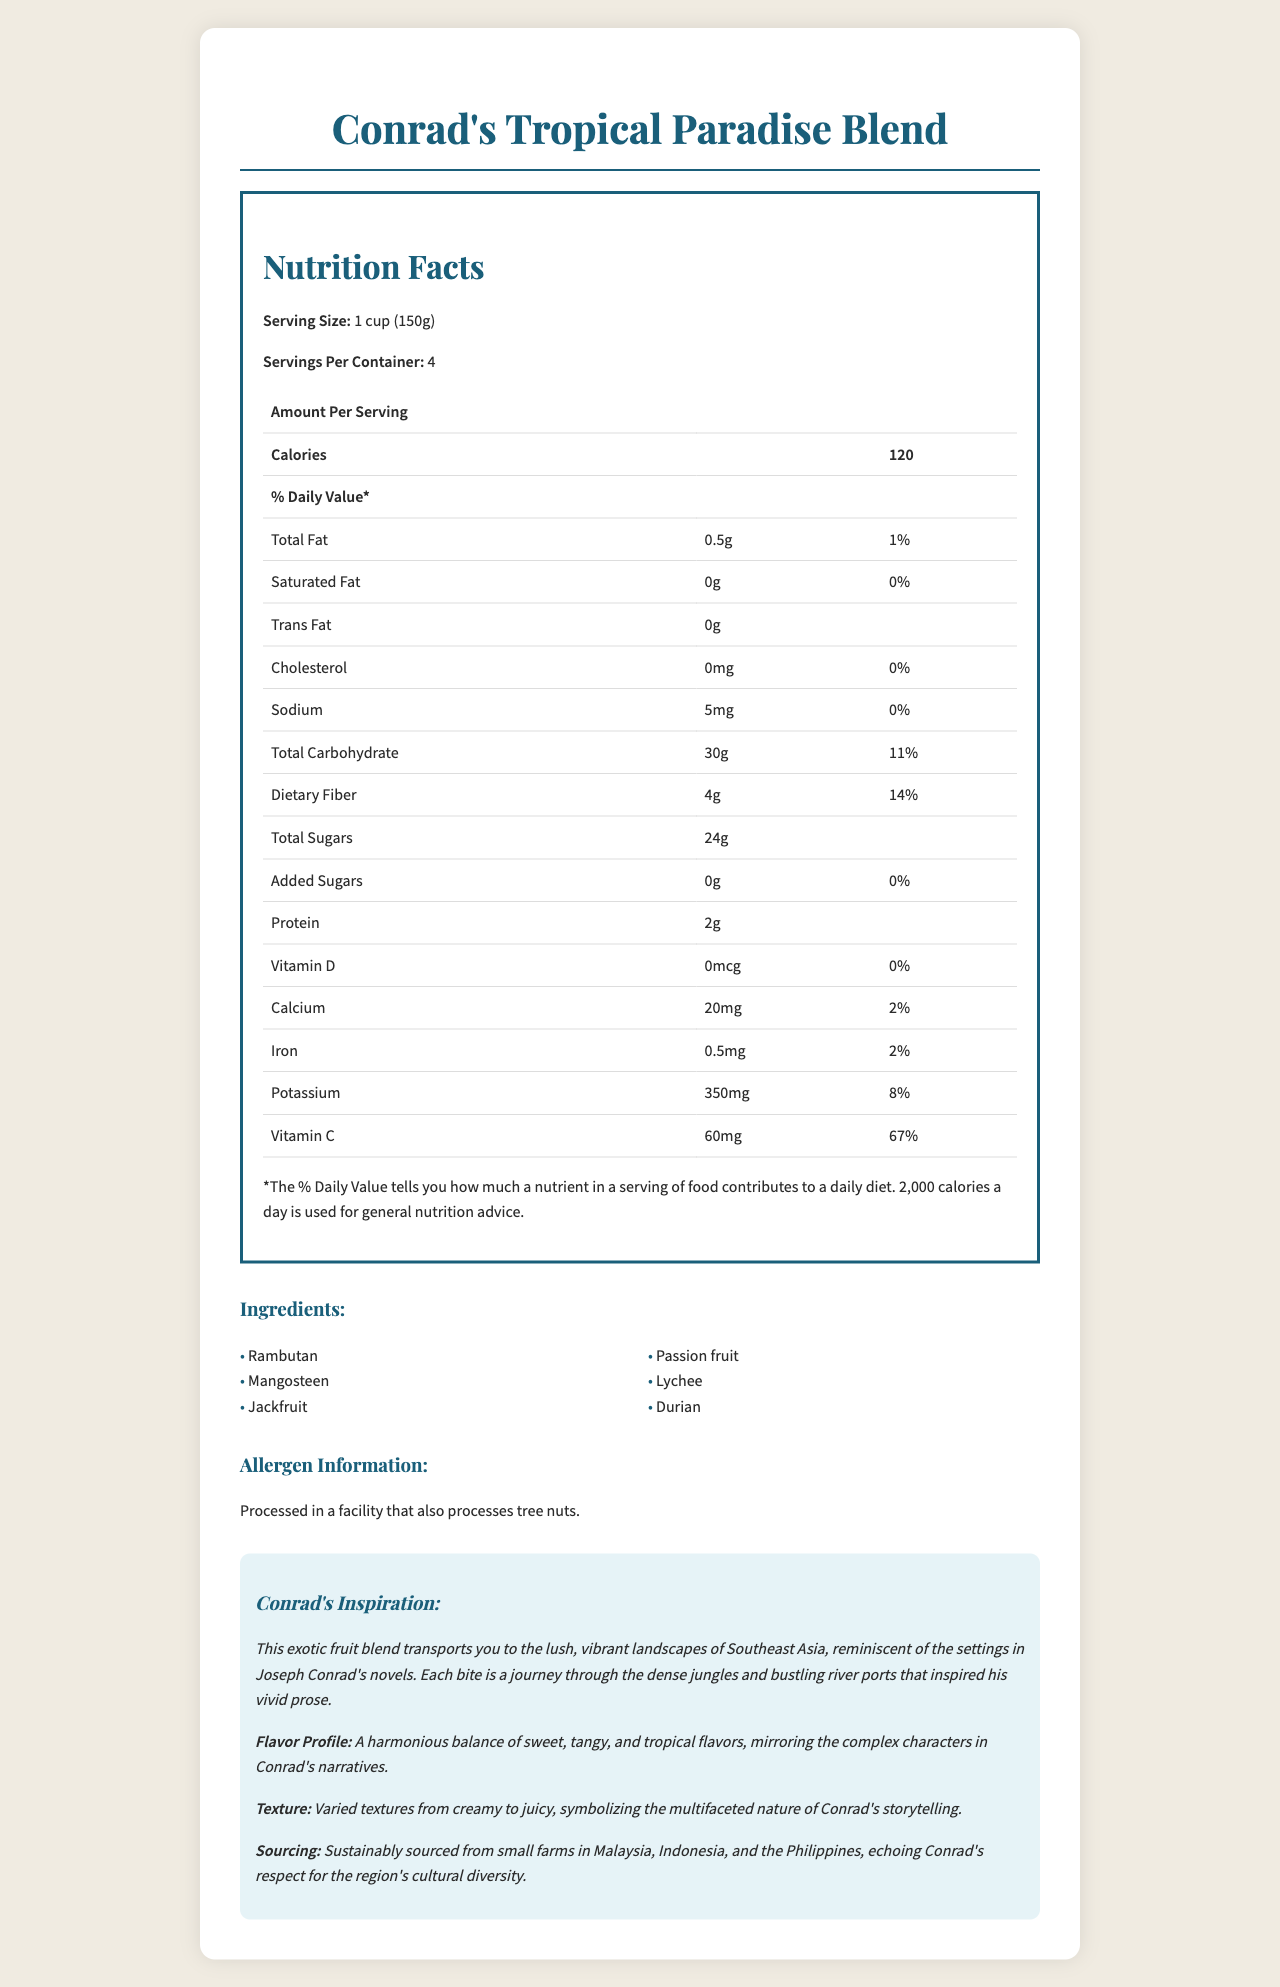what is the serving size of Conrad's Tropical Paradise Blend? The serving size is explicitly stated as "1 cup (150g)" in the nutrition facts section.
Answer: 1 cup (150g) how many calories are in one serving? The calories per serving are listed as 120 in the nutrition facts section.
Answer: 120 what is the total fat content per serving? The total fat content per serving is 0.5g, mentioned under the Total Fat entry.
Answer: 0.5g how many grams of dietary fiber does one serving contain? The dietary fiber per serving is detailed as 4g in the nutrition facts table.
Answer: 4g What fruits are included in the ingredients list? The ingredients listed are Rambutan, Mangosteen, Jackfruit, Passion fruit, Lychee, and Durian.
Answer: Rambutan, Mangosteen, Jackfruit, Passion fruit, Lychee, Durian how much sodium does one serving contain? The sodium content per serving is listed as 5mg in the nutrition facts table.
Answer: 5mg Are there any added sugars in this product? Yes/No The entry for added sugars explicitly states "0g", meaning there are no added sugars.
Answer: No Which nutrient has the highest % Daily Value? A. Vitamin D B. Vitamin C C. Calcium D. Iron Vitamin C has the highest daily value at 67%, as listed in the nutrition facts table.
Answer: B. Vitamin C What is the % Daily Value of calcium? A. 2% B. 8% C. 67% D. 14% The calcium % Daily Value is listed as 2% in the nutrition facts section.
Answer: A. 2% What is the texture description of the fruit blend? The document describes the texture as "Varied textures from creamy to juicy."
Answer: Varied textures from creamy to juicy Is the fruit blend processed in a facility that also handles tree nuts? The allergen information explicitly states that it is "Processed in a facility that also processes tree nuts."
Answer: Yes Summarize the main idea of the document. The document details a fruit blend inspired by Southeast Asia, emphasizing its exotic ingredients, nutritional facts, textual description, and allergenic information.
Answer: Conrad's Tropical Paradise Blend is an exotic fruit mix inspired by Southeast Asia, containing fruits like Rambutan and Durian, boasting balanced flavors and varied textures, with detailed nutritional information provided. What is the exact product weight in grams for the entire container? With each serving size being 150g and there being 4 servings per container (150g x 4), the total weight is 600g.
Answer: 600g Can the exact amount of cholesterol in mg be determined from the document? While the cholesterol amount is listed as 0mg, there is no mention of the total milligram amount beyond zero, meaning no exact numerical value beyond "0mg" can be calculated if trace elements less than 1mg were present.
Answer: No, it cannot be determined 